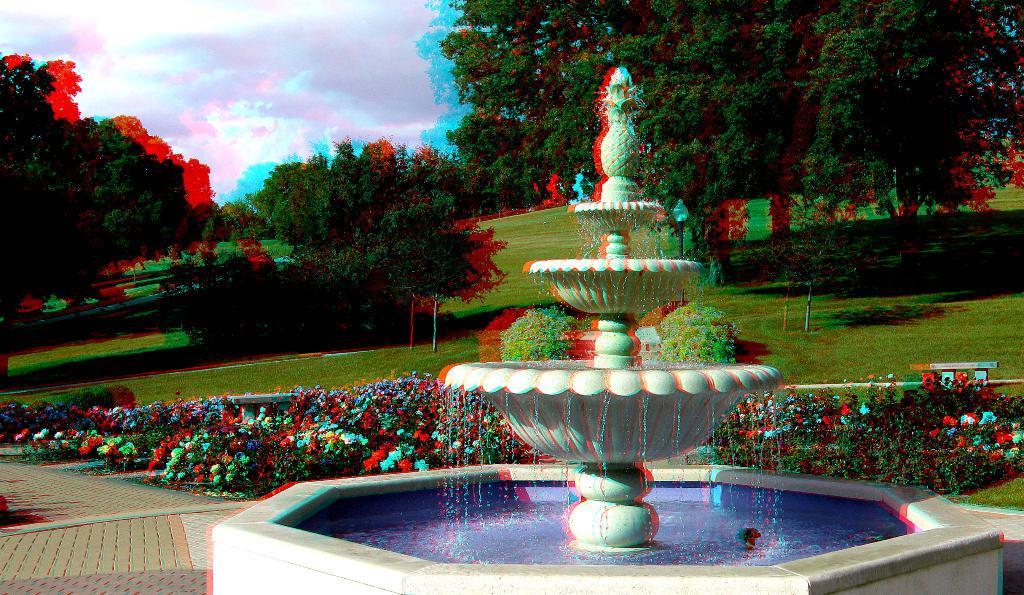Can you describe this image briefly? In this picture we can see a fountain with water, path, flowers, plants, grass, trees and some objects and in the background we can see the sky with clouds. 